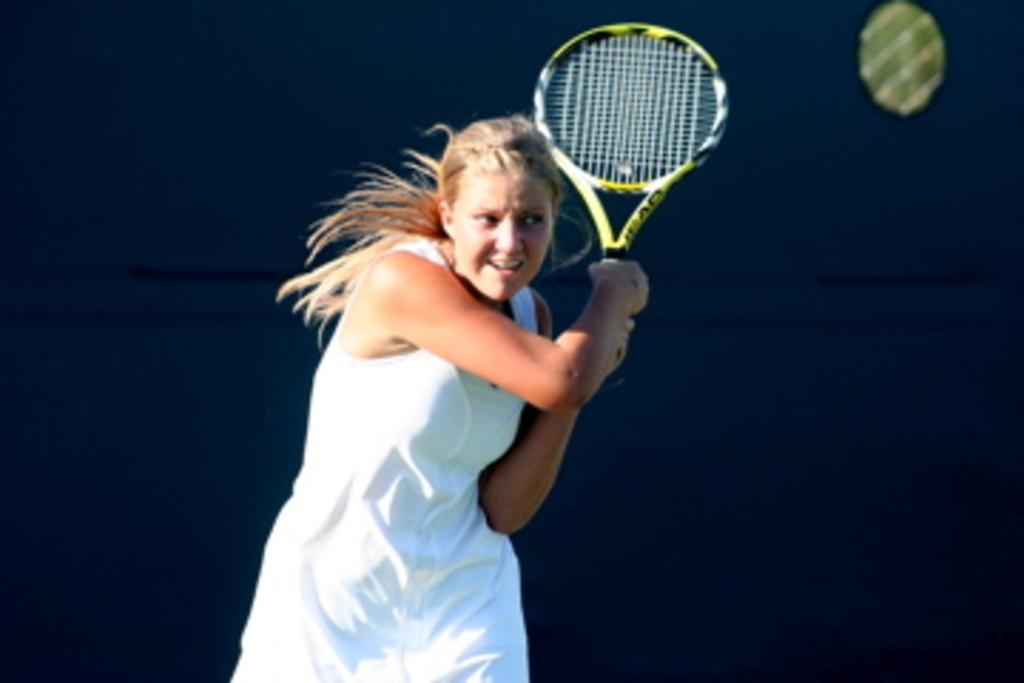Please provide a concise description of this image. In the image there is a woman playing tennis. 